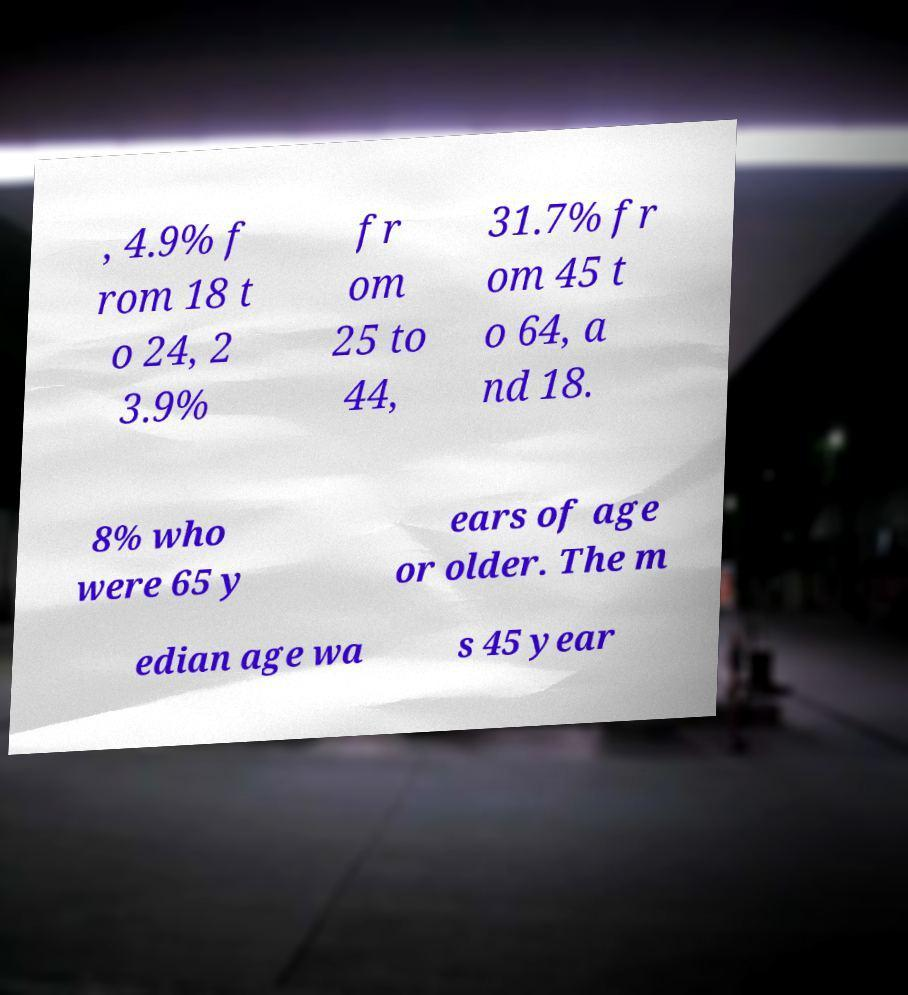Can you accurately transcribe the text from the provided image for me? , 4.9% f rom 18 t o 24, 2 3.9% fr om 25 to 44, 31.7% fr om 45 t o 64, a nd 18. 8% who were 65 y ears of age or older. The m edian age wa s 45 year 